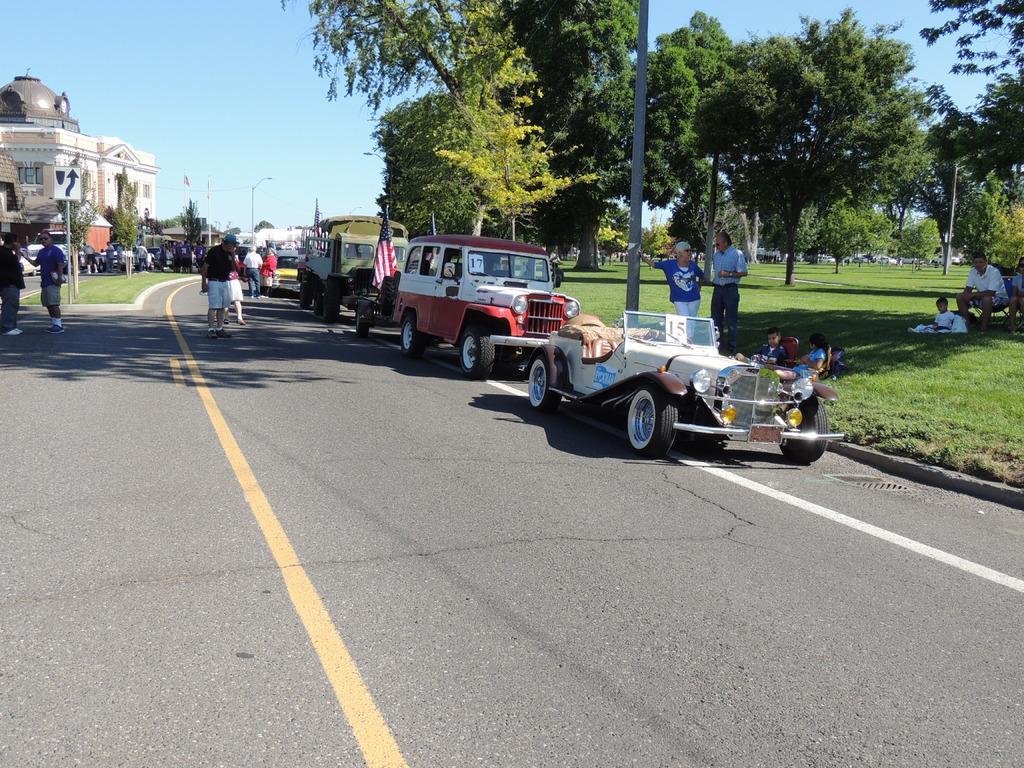Describe this image in one or two sentences. There are some vehicles parked on the road as we can see in the middle of this image. There are some persons standing on the left side of this image and right side of this image. There are some trees in the background. There is a building on the left side of this image, and there is a sky at the top of this image. 